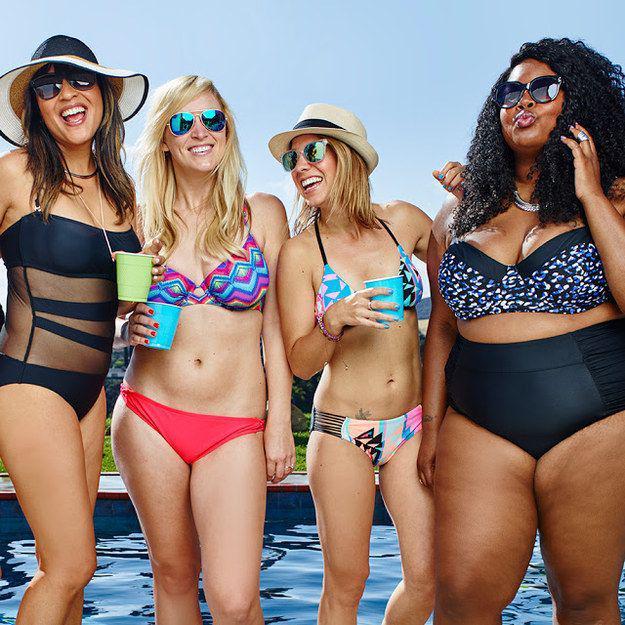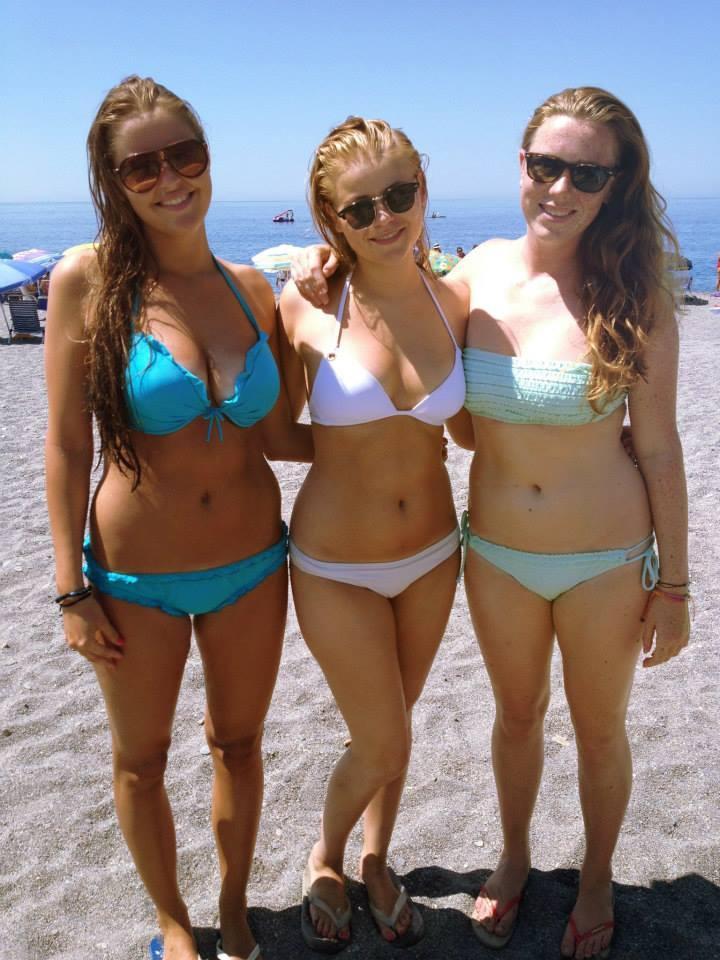The first image is the image on the left, the second image is the image on the right. Given the left and right images, does the statement "One image contains exactly three bikini models, and the other image contains no more than two bikini models and includes a blue bikini bottom and an orange bikini top." hold true? Answer yes or no. No. The first image is the image on the left, the second image is the image on the right. Assess this claim about the two images: "One of the images contains exactly two women in swimsuits.". Correct or not? Answer yes or no. No. 